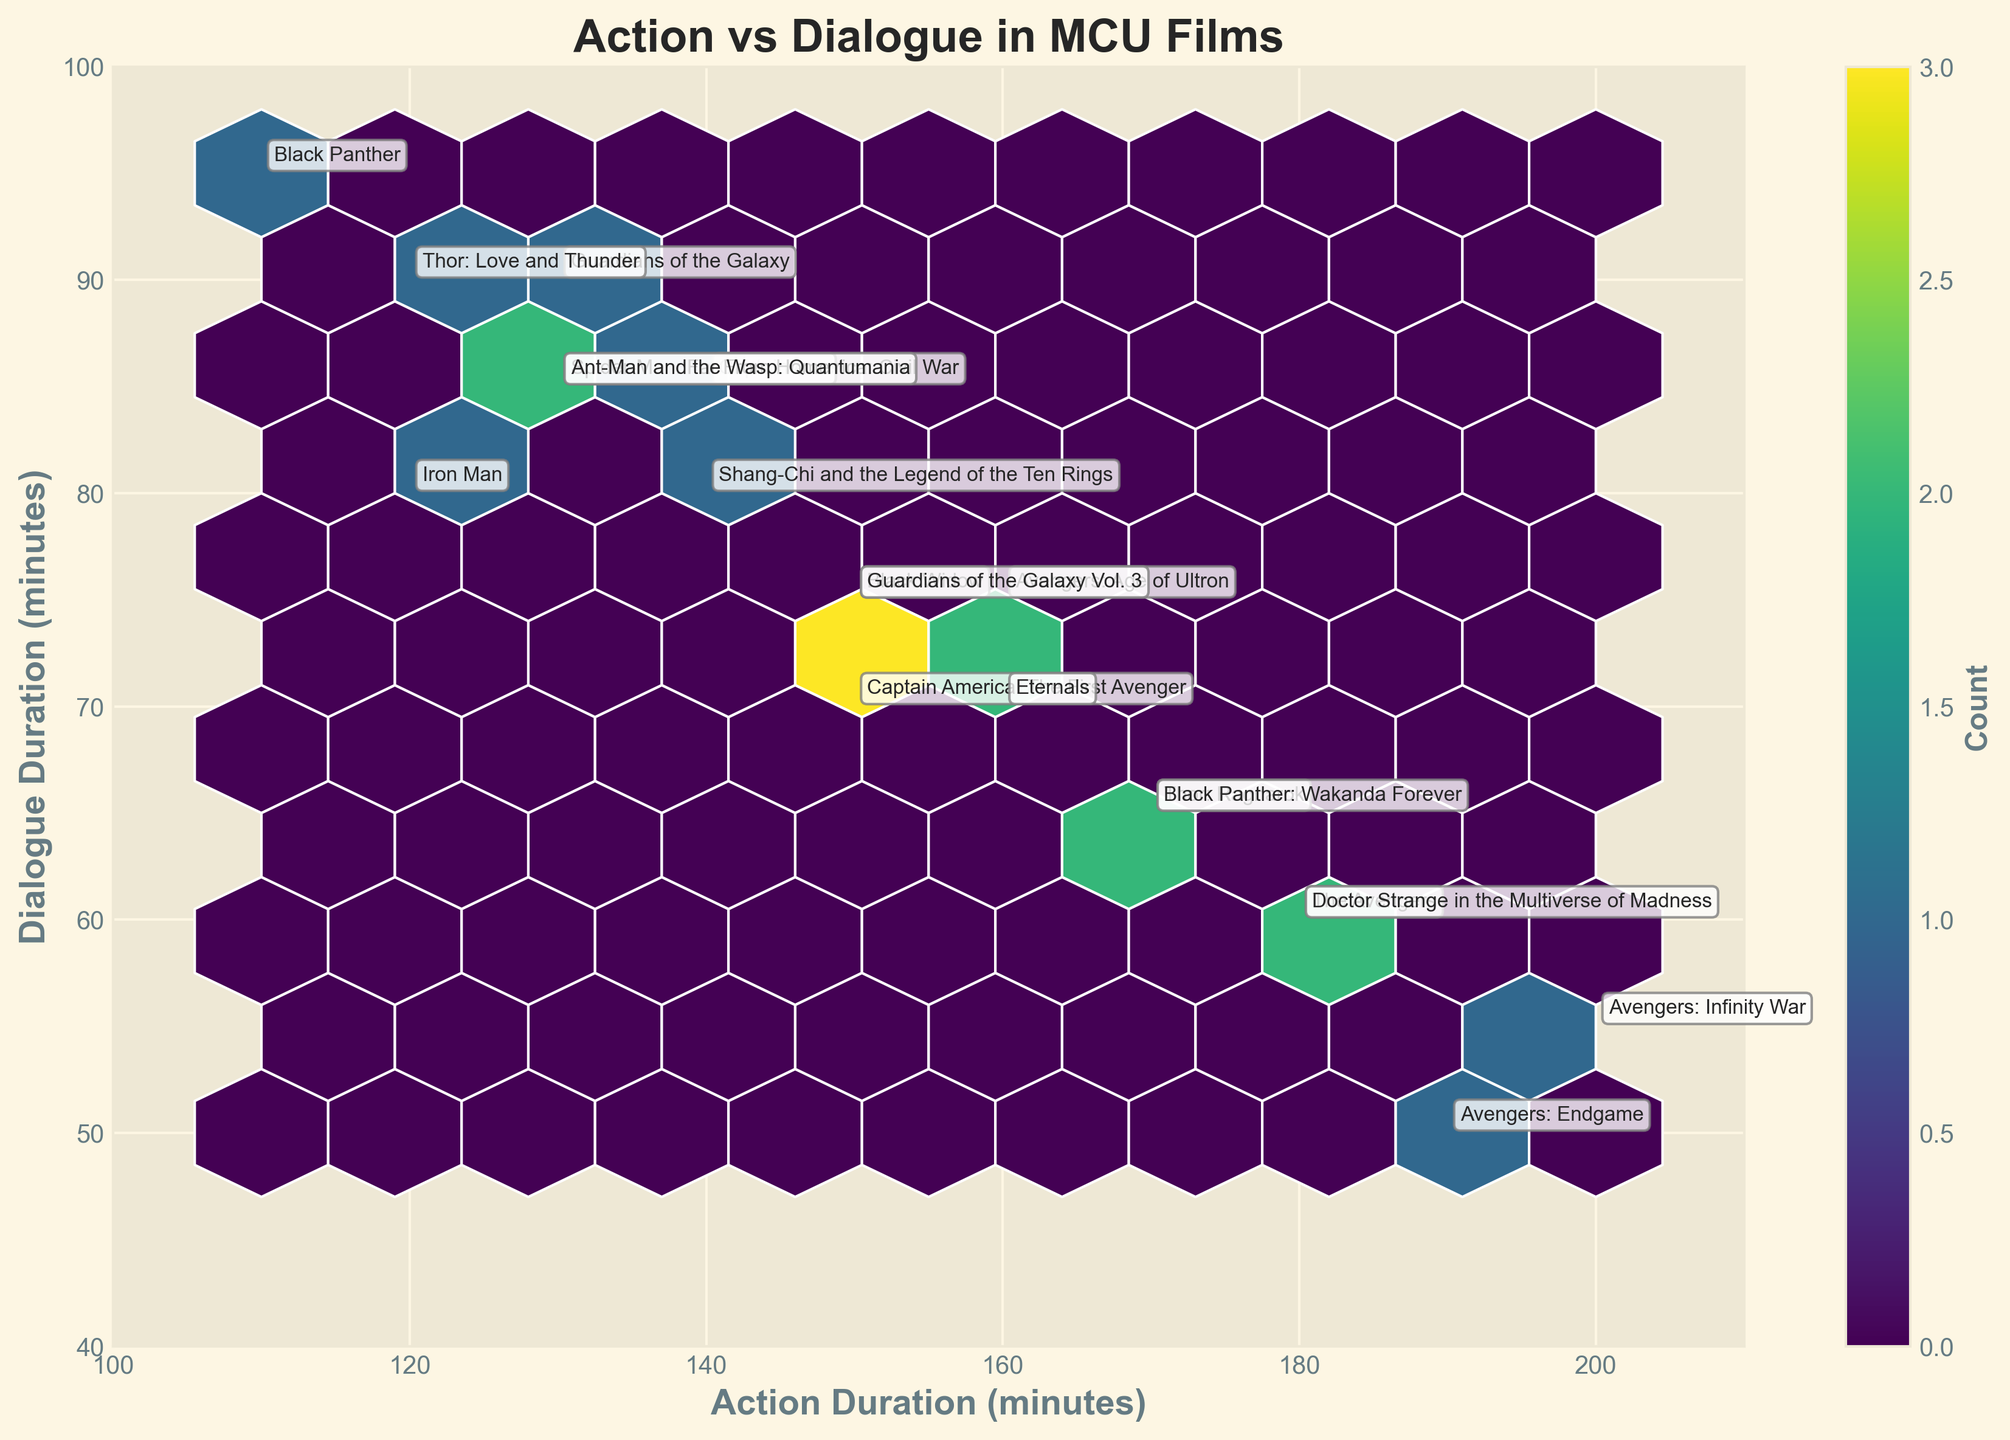What is the title of the plot? The title is often located at the top of the plot and provides a brief description of what the plot represents. In this case, it should be directly readable from the top center of the figure.
Answer: Action vs Dialogue in MCU Films What are the axes labels? Axes labels describe what each axis represents. The x-axis label is usually horizontal at the bottom and the y-axis label is usually vertical on the left side.
Answer: Action Duration (minutes) and Dialogue Duration (minutes) What color is used for the hexagonal bins? The color of the hexagonal bins can be observed from the color scheme used in the plot, which, according to the code, is 'viridis'. The bins show various shades of this color based on frequency.
Answer: Shades of viridis Which film has the longest action duration and what is the duration? This can be found by identifying the film label corresponding to the highest x-axis value. In the plot, the film label should be "Avengers: Infinity War" at 200 minutes.
Answer: Avengers: Infinity War, 200 minutes Which film has the longest dialogue duration and what is the duration? This can be found by identifying the film label corresponding to the highest y-axis value. In the plot, the film label should be "Black Panther" at 95 minutes.
Answer: Black Panther, 95 minutes How many films have an action duration greater than 150 minutes? To answer this, count the number of film labels positioned to the right of the 150-minute mark on the x-axis. These films are Captain America: The First Avenger, The Avengers, Avengers: Age of Ultron, Thor: Ragnarok, Avengers: Infinity War, Avengers: Endgame, Doctor Strange in the Multiverse of Madness, and Black Panther: Wakanda Forever.
Answer: 8 What is the average dialogue duration for films with action durations between 140 and 160 minutes? Identify the films within the action duration range of 140 to 160 minutes (Captain America: Civil War, Black Widow, Shang-Chi and the Legend of the Ten Rings, and Eternals), sum their dialogue durations (85 + 75 + 80 + 70 = 310), and divide by the number of films (310/4).
Answer: 77.5 minutes Which films have equal action and dialogue durations? Check the plot for film labels where the x and y coordinates fall on the same position (this would be on a 45-degree diagonal line if visualized). According to the provided data, no such films exist.
Answer: None How does the frequency of action sequences compare to dialogue sequences across the films? To understand this, interpret the color intensity of the hexagonal bins on the plot. Darker shades indicate higher frequency. Most bins have darker shades on the upper left, indicating more films have higher action durations coinciding with lower dialogue durations.
Answer: Higher action durations often coincide with lower dialogue durations 